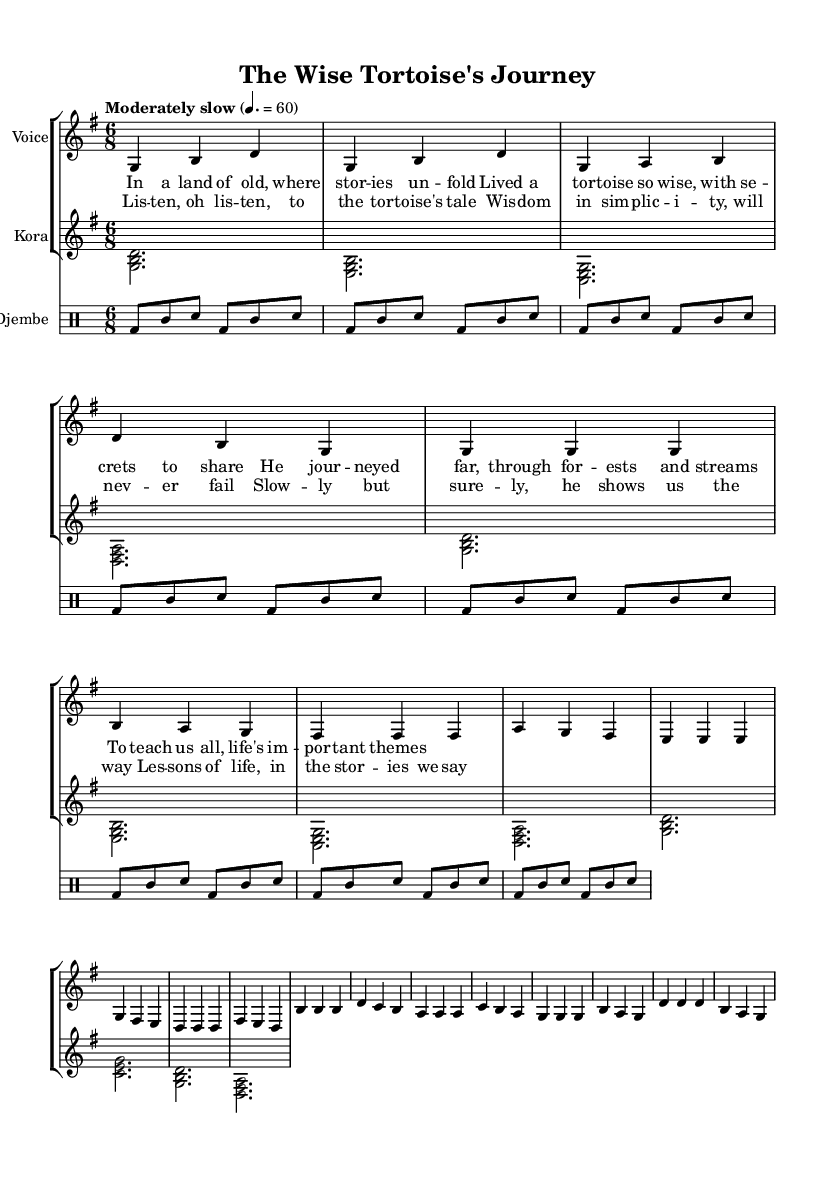What is the key signature of this music? The key signature is G major, which has one sharp (F#). This can be determined by looking at the key signature indicator at the beginning of the staff.
Answer: G major What is the time signature of this piece? The time signature is 6/8, which indicates that there are six eighth notes in each measure. This can be found at the beginning of the sheet music, next to the key signature.
Answer: 6/8 What is the tempo marking for this piece? The tempo marking is "Moderately slow," indicated above the staff with a metronome marking of 60. This means the piece is to be played at a moderate pace.
Answer: Moderately slow Which instrument plays the introduction? The introduction is played by the voice, indicated by the notes above the kora and djembe lines at the beginning of the score. Since the voice starts the musical line, it is the answering instrument.
Answer: Voice How many lines are in the verse lyrics? The verse lyrics have four lines. This can be counted directly from the lyric section provided below the voice staff. Each line of text corresponds to the lengths of musical phrases given.
Answer: Four lines What theme does the chorus reflect? The chorus reflects the theme of wisdom and simplicity, as described in the lyrics that advocate listening to the tortoise's tale and the moral lessons drawn from it. This theme aligns with the nature of traditional storytelling in African music.
Answer: Wisdom and simplicity What rhythmic pattern is used in the djembe part? The rhythmic pattern used in the djembe part consists of alternating bass and snare hits with tambourine accents, repeated throughout the section. This can be observed in the drumming notation under the djembe staff.
Answer: Bass and snare with tambourine 